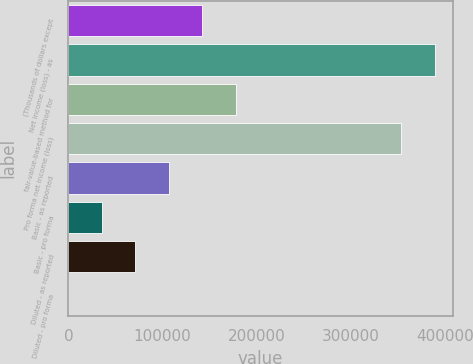<chart> <loc_0><loc_0><loc_500><loc_500><bar_chart><fcel>(Thousands of dollars except<fcel>Net income (loss) - as<fcel>fair-value-based method for<fcel>Pro forma net income (loss)<fcel>Basic - as reported<fcel>Basic - pro forma<fcel>Diluted - as reported<fcel>Diluted - pro forma<nl><fcel>142385<fcel>389218<fcel>177981<fcel>353622<fcel>106789<fcel>35596.9<fcel>71192.9<fcel>0.86<nl></chart> 